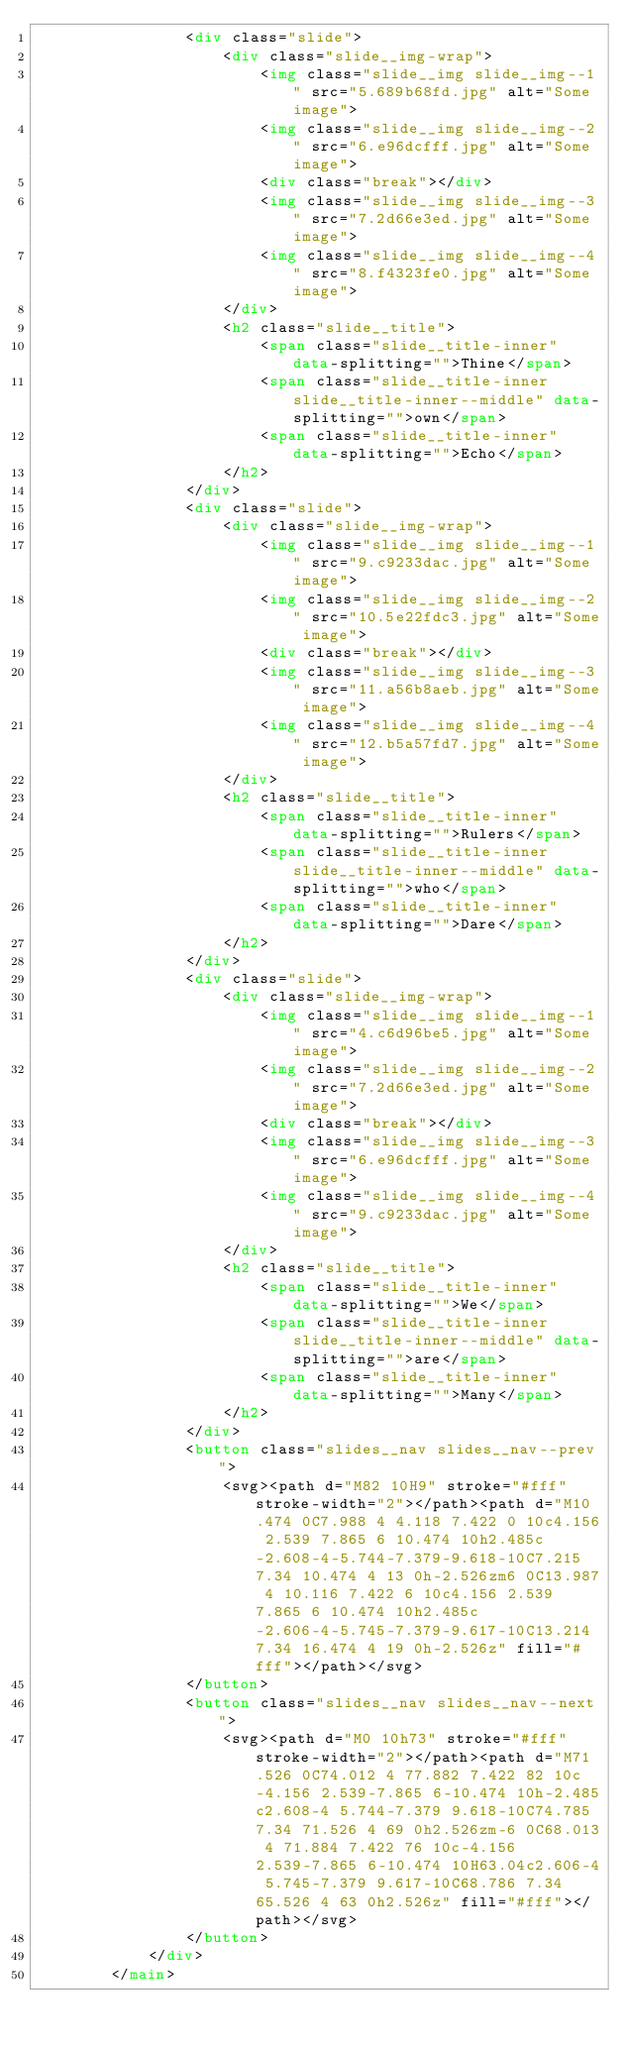Convert code to text. <code><loc_0><loc_0><loc_500><loc_500><_HTML_>				<div class="slide">
					<div class="slide__img-wrap">
						<img class="slide__img slide__img--1" src="5.689b68fd.jpg" alt="Some image">
						<img class="slide__img slide__img--2" src="6.e96dcfff.jpg" alt="Some image">
						<div class="break"></div>
						<img class="slide__img slide__img--3" src="7.2d66e3ed.jpg" alt="Some image">
						<img class="slide__img slide__img--4" src="8.f4323fe0.jpg" alt="Some image">
					</div>
					<h2 class="slide__title">
						<span class="slide__title-inner" data-splitting="">Thine</span>
						<span class="slide__title-inner slide__title-inner--middle" data-splitting="">own</span>
						<span class="slide__title-inner" data-splitting="">Echo</span>
					</h2>
				</div>
				<div class="slide">
					<div class="slide__img-wrap">
						<img class="slide__img slide__img--1" src="9.c9233dac.jpg" alt="Some image">
						<img class="slide__img slide__img--2" src="10.5e22fdc3.jpg" alt="Some image">
						<div class="break"></div>
						<img class="slide__img slide__img--3" src="11.a56b8aeb.jpg" alt="Some image">
						<img class="slide__img slide__img--4" src="12.b5a57fd7.jpg" alt="Some image">
					</div>
					<h2 class="slide__title">
						<span class="slide__title-inner" data-splitting="">Rulers</span>
						<span class="slide__title-inner slide__title-inner--middle" data-splitting="">who</span>
						<span class="slide__title-inner" data-splitting="">Dare</span>
					</h2>
				</div>
				<div class="slide">
					<div class="slide__img-wrap">
						<img class="slide__img slide__img--1" src="4.c6d96be5.jpg" alt="Some image">
						<img class="slide__img slide__img--2" src="7.2d66e3ed.jpg" alt="Some image">
						<div class="break"></div>
						<img class="slide__img slide__img--3" src="6.e96dcfff.jpg" alt="Some image">
						<img class="slide__img slide__img--4" src="9.c9233dac.jpg" alt="Some image">
					</div>
					<h2 class="slide__title">
						<span class="slide__title-inner" data-splitting="">We</span>
						<span class="slide__title-inner slide__title-inner--middle" data-splitting="">are</span>
						<span class="slide__title-inner" data-splitting="">Many</span>
					</h2>
				</div>
				<button class="slides__nav slides__nav--prev">
					<svg><path d="M82 10H9" stroke="#fff" stroke-width="2"></path><path d="M10.474 0C7.988 4 4.118 7.422 0 10c4.156 2.539 7.865 6 10.474 10h2.485c-2.608-4-5.744-7.379-9.618-10C7.215 7.34 10.474 4 13 0h-2.526zm6 0C13.987 4 10.116 7.422 6 10c4.156 2.539 7.865 6 10.474 10h2.485c-2.606-4-5.745-7.379-9.617-10C13.214 7.34 16.474 4 19 0h-2.526z" fill="#fff"></path></svg>
				</button>
				<button class="slides__nav slides__nav--next">
					<svg><path d="M0 10h73" stroke="#fff" stroke-width="2"></path><path d="M71.526 0C74.012 4 77.882 7.422 82 10c-4.156 2.539-7.865 6-10.474 10h-2.485c2.608-4 5.744-7.379 9.618-10C74.785 7.34 71.526 4 69 0h2.526zm-6 0C68.013 4 71.884 7.422 76 10c-4.156 2.539-7.865 6-10.474 10H63.04c2.606-4 5.745-7.379 9.617-10C68.786 7.34 65.526 4 63 0h2.526z" fill="#fff"></path></svg>
				</button>
			</div>
		</main></code> 